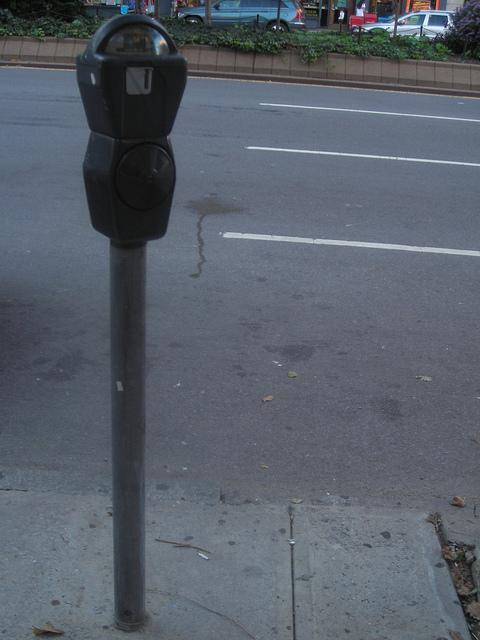How many cups are there?
Give a very brief answer. 0. How many parking meters are there?
Give a very brief answer. 1. How many people are wearing yellow and red jackets?
Give a very brief answer. 0. 